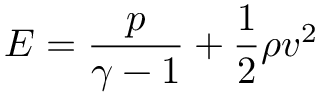Convert formula to latex. <formula><loc_0><loc_0><loc_500><loc_500>E = \frac { p } { \gamma - 1 } + \frac { 1 } { 2 } \rho v ^ { 2 }</formula> 